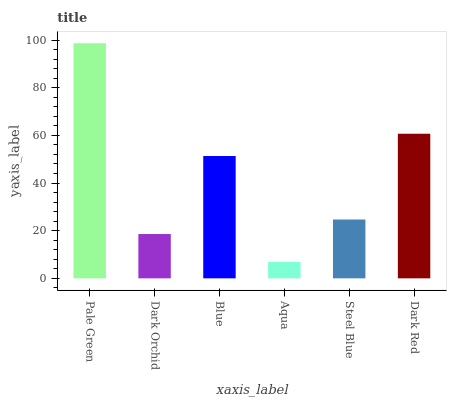Is Aqua the minimum?
Answer yes or no. Yes. Is Pale Green the maximum?
Answer yes or no. Yes. Is Dark Orchid the minimum?
Answer yes or no. No. Is Dark Orchid the maximum?
Answer yes or no. No. Is Pale Green greater than Dark Orchid?
Answer yes or no. Yes. Is Dark Orchid less than Pale Green?
Answer yes or no. Yes. Is Dark Orchid greater than Pale Green?
Answer yes or no. No. Is Pale Green less than Dark Orchid?
Answer yes or no. No. Is Blue the high median?
Answer yes or no. Yes. Is Steel Blue the low median?
Answer yes or no. Yes. Is Pale Green the high median?
Answer yes or no. No. Is Blue the low median?
Answer yes or no. No. 